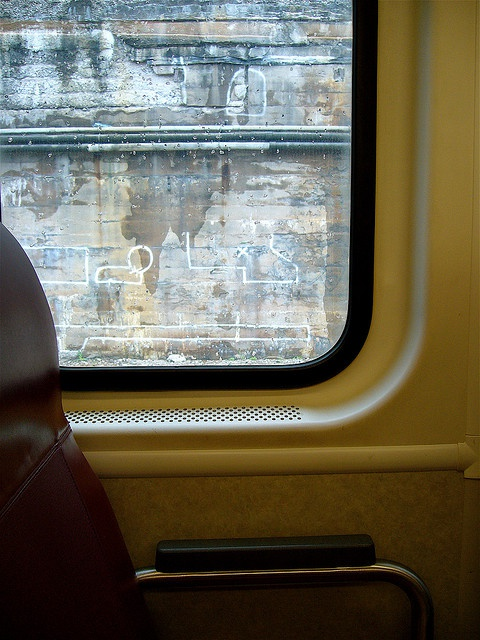Describe the objects in this image and their specific colors. I can see train in black, olive, darkgray, lightgray, and maroon tones and chair in gray, black, and darkgreen tones in this image. 